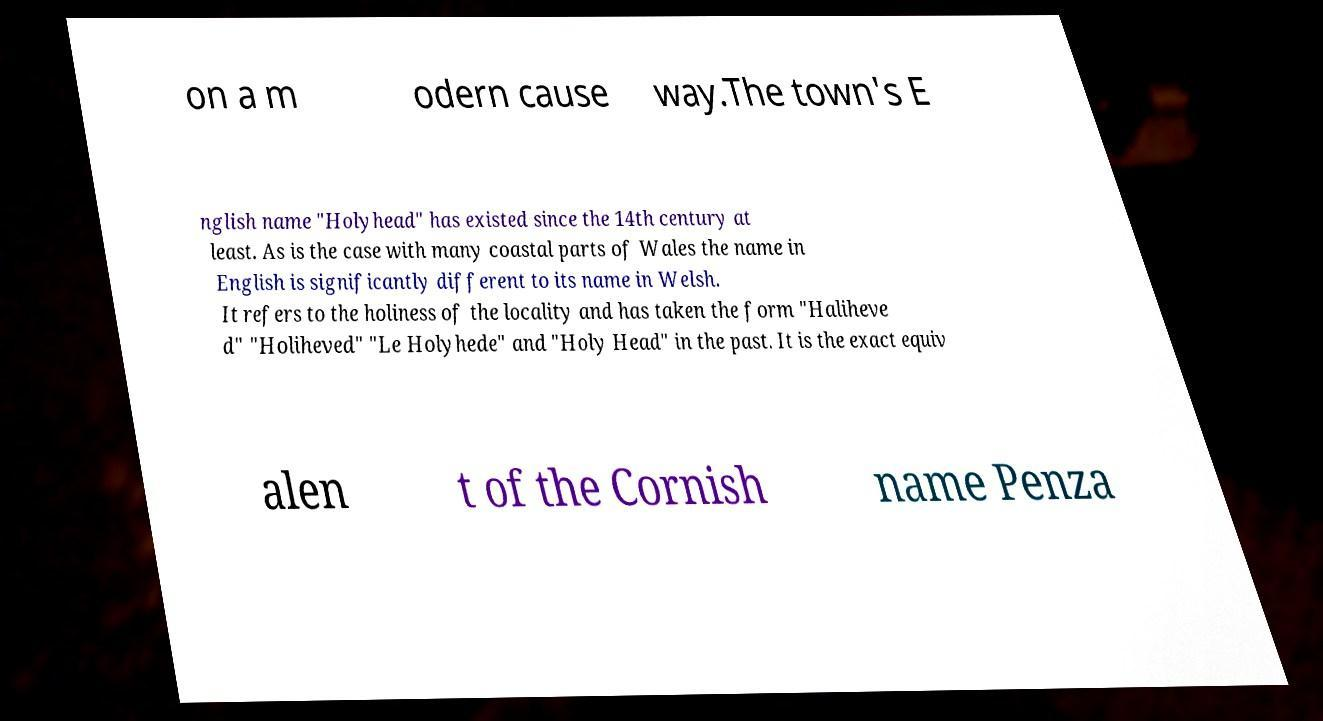Could you extract and type out the text from this image? on a m odern cause way.The town's E nglish name "Holyhead" has existed since the 14th century at least. As is the case with many coastal parts of Wales the name in English is significantly different to its name in Welsh. It refers to the holiness of the locality and has taken the form "Haliheve d" "Holiheved" "Le Holyhede" and "Holy Head" in the past. It is the exact equiv alen t of the Cornish name Penza 